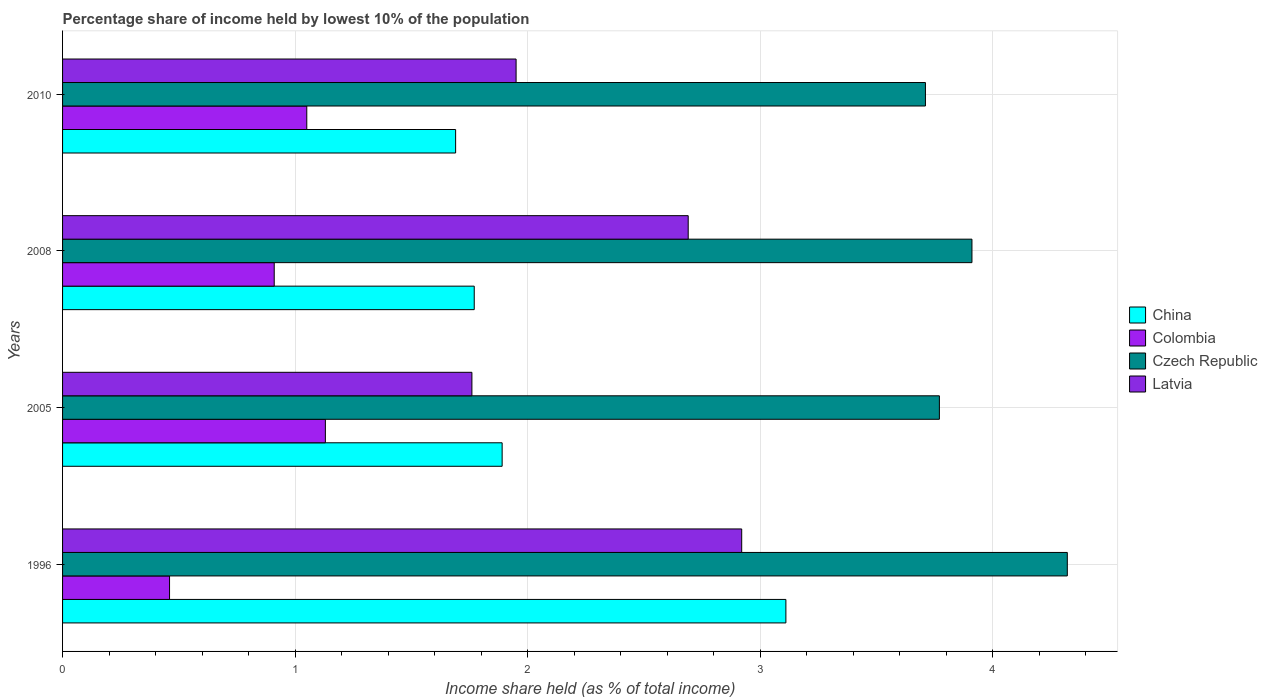How many groups of bars are there?
Your response must be concise. 4. What is the label of the 4th group of bars from the top?
Ensure brevity in your answer.  1996. In how many cases, is the number of bars for a given year not equal to the number of legend labels?
Keep it short and to the point. 0. What is the percentage share of income held by lowest 10% of the population in China in 2008?
Your answer should be compact. 1.77. Across all years, what is the maximum percentage share of income held by lowest 10% of the population in Czech Republic?
Offer a very short reply. 4.32. Across all years, what is the minimum percentage share of income held by lowest 10% of the population in Latvia?
Make the answer very short. 1.76. In which year was the percentage share of income held by lowest 10% of the population in Latvia maximum?
Provide a succinct answer. 1996. In which year was the percentage share of income held by lowest 10% of the population in Colombia minimum?
Ensure brevity in your answer.  1996. What is the total percentage share of income held by lowest 10% of the population in Czech Republic in the graph?
Ensure brevity in your answer.  15.71. What is the difference between the percentage share of income held by lowest 10% of the population in Czech Republic in 2008 and that in 2010?
Make the answer very short. 0.2. What is the difference between the percentage share of income held by lowest 10% of the population in Latvia in 2005 and the percentage share of income held by lowest 10% of the population in Czech Republic in 2008?
Provide a succinct answer. -2.15. What is the average percentage share of income held by lowest 10% of the population in Colombia per year?
Provide a succinct answer. 0.89. What is the ratio of the percentage share of income held by lowest 10% of the population in Colombia in 1996 to that in 2008?
Offer a terse response. 0.51. Is the percentage share of income held by lowest 10% of the population in China in 1996 less than that in 2008?
Keep it short and to the point. No. Is the difference between the percentage share of income held by lowest 10% of the population in Colombia in 1996 and 2005 greater than the difference between the percentage share of income held by lowest 10% of the population in Czech Republic in 1996 and 2005?
Give a very brief answer. No. What is the difference between the highest and the second highest percentage share of income held by lowest 10% of the population in China?
Your response must be concise. 1.22. What is the difference between the highest and the lowest percentage share of income held by lowest 10% of the population in China?
Your response must be concise. 1.42. Is the sum of the percentage share of income held by lowest 10% of the population in Czech Republic in 2005 and 2010 greater than the maximum percentage share of income held by lowest 10% of the population in Latvia across all years?
Offer a terse response. Yes. Is it the case that in every year, the sum of the percentage share of income held by lowest 10% of the population in Czech Republic and percentage share of income held by lowest 10% of the population in Latvia is greater than the sum of percentage share of income held by lowest 10% of the population in China and percentage share of income held by lowest 10% of the population in Colombia?
Your answer should be compact. No. What does the 1st bar from the top in 2005 represents?
Provide a short and direct response. Latvia. What does the 3rd bar from the bottom in 1996 represents?
Provide a short and direct response. Czech Republic. Is it the case that in every year, the sum of the percentage share of income held by lowest 10% of the population in Czech Republic and percentage share of income held by lowest 10% of the population in Latvia is greater than the percentage share of income held by lowest 10% of the population in Colombia?
Keep it short and to the point. Yes. What is the difference between two consecutive major ticks on the X-axis?
Offer a terse response. 1. Does the graph contain any zero values?
Your answer should be very brief. No. Does the graph contain grids?
Provide a succinct answer. Yes. Where does the legend appear in the graph?
Offer a terse response. Center right. What is the title of the graph?
Your response must be concise. Percentage share of income held by lowest 10% of the population. Does "St. Lucia" appear as one of the legend labels in the graph?
Your answer should be compact. No. What is the label or title of the X-axis?
Give a very brief answer. Income share held (as % of total income). What is the label or title of the Y-axis?
Keep it short and to the point. Years. What is the Income share held (as % of total income) of China in 1996?
Provide a succinct answer. 3.11. What is the Income share held (as % of total income) in Colombia in 1996?
Offer a terse response. 0.46. What is the Income share held (as % of total income) in Czech Republic in 1996?
Ensure brevity in your answer.  4.32. What is the Income share held (as % of total income) of Latvia in 1996?
Your answer should be compact. 2.92. What is the Income share held (as % of total income) of China in 2005?
Provide a short and direct response. 1.89. What is the Income share held (as % of total income) of Colombia in 2005?
Your answer should be compact. 1.13. What is the Income share held (as % of total income) of Czech Republic in 2005?
Provide a succinct answer. 3.77. What is the Income share held (as % of total income) in Latvia in 2005?
Provide a succinct answer. 1.76. What is the Income share held (as % of total income) of China in 2008?
Give a very brief answer. 1.77. What is the Income share held (as % of total income) of Colombia in 2008?
Keep it short and to the point. 0.91. What is the Income share held (as % of total income) in Czech Republic in 2008?
Provide a short and direct response. 3.91. What is the Income share held (as % of total income) of Latvia in 2008?
Make the answer very short. 2.69. What is the Income share held (as % of total income) of China in 2010?
Your answer should be very brief. 1.69. What is the Income share held (as % of total income) of Colombia in 2010?
Provide a succinct answer. 1.05. What is the Income share held (as % of total income) in Czech Republic in 2010?
Offer a very short reply. 3.71. What is the Income share held (as % of total income) in Latvia in 2010?
Ensure brevity in your answer.  1.95. Across all years, what is the maximum Income share held (as % of total income) of China?
Your answer should be very brief. 3.11. Across all years, what is the maximum Income share held (as % of total income) in Colombia?
Your answer should be compact. 1.13. Across all years, what is the maximum Income share held (as % of total income) in Czech Republic?
Ensure brevity in your answer.  4.32. Across all years, what is the maximum Income share held (as % of total income) in Latvia?
Provide a succinct answer. 2.92. Across all years, what is the minimum Income share held (as % of total income) of China?
Your response must be concise. 1.69. Across all years, what is the minimum Income share held (as % of total income) of Colombia?
Make the answer very short. 0.46. Across all years, what is the minimum Income share held (as % of total income) of Czech Republic?
Make the answer very short. 3.71. Across all years, what is the minimum Income share held (as % of total income) of Latvia?
Ensure brevity in your answer.  1.76. What is the total Income share held (as % of total income) of China in the graph?
Ensure brevity in your answer.  8.46. What is the total Income share held (as % of total income) in Colombia in the graph?
Provide a short and direct response. 3.55. What is the total Income share held (as % of total income) in Czech Republic in the graph?
Your response must be concise. 15.71. What is the total Income share held (as % of total income) in Latvia in the graph?
Give a very brief answer. 9.32. What is the difference between the Income share held (as % of total income) of China in 1996 and that in 2005?
Your answer should be compact. 1.22. What is the difference between the Income share held (as % of total income) of Colombia in 1996 and that in 2005?
Give a very brief answer. -0.67. What is the difference between the Income share held (as % of total income) in Czech Republic in 1996 and that in 2005?
Make the answer very short. 0.55. What is the difference between the Income share held (as % of total income) in Latvia in 1996 and that in 2005?
Your answer should be very brief. 1.16. What is the difference between the Income share held (as % of total income) of China in 1996 and that in 2008?
Make the answer very short. 1.34. What is the difference between the Income share held (as % of total income) in Colombia in 1996 and that in 2008?
Offer a terse response. -0.45. What is the difference between the Income share held (as % of total income) in Czech Republic in 1996 and that in 2008?
Offer a terse response. 0.41. What is the difference between the Income share held (as % of total income) of Latvia in 1996 and that in 2008?
Offer a terse response. 0.23. What is the difference between the Income share held (as % of total income) in China in 1996 and that in 2010?
Your answer should be compact. 1.42. What is the difference between the Income share held (as % of total income) of Colombia in 1996 and that in 2010?
Offer a terse response. -0.59. What is the difference between the Income share held (as % of total income) of Czech Republic in 1996 and that in 2010?
Provide a succinct answer. 0.61. What is the difference between the Income share held (as % of total income) of China in 2005 and that in 2008?
Make the answer very short. 0.12. What is the difference between the Income share held (as % of total income) in Colombia in 2005 and that in 2008?
Offer a very short reply. 0.22. What is the difference between the Income share held (as % of total income) in Czech Republic in 2005 and that in 2008?
Keep it short and to the point. -0.14. What is the difference between the Income share held (as % of total income) in Latvia in 2005 and that in 2008?
Ensure brevity in your answer.  -0.93. What is the difference between the Income share held (as % of total income) of Colombia in 2005 and that in 2010?
Offer a very short reply. 0.08. What is the difference between the Income share held (as % of total income) in Latvia in 2005 and that in 2010?
Your response must be concise. -0.19. What is the difference between the Income share held (as % of total income) of China in 2008 and that in 2010?
Offer a terse response. 0.08. What is the difference between the Income share held (as % of total income) of Colombia in 2008 and that in 2010?
Your answer should be very brief. -0.14. What is the difference between the Income share held (as % of total income) in Latvia in 2008 and that in 2010?
Keep it short and to the point. 0.74. What is the difference between the Income share held (as % of total income) in China in 1996 and the Income share held (as % of total income) in Colombia in 2005?
Keep it short and to the point. 1.98. What is the difference between the Income share held (as % of total income) of China in 1996 and the Income share held (as % of total income) of Czech Republic in 2005?
Your answer should be very brief. -0.66. What is the difference between the Income share held (as % of total income) of China in 1996 and the Income share held (as % of total income) of Latvia in 2005?
Your answer should be very brief. 1.35. What is the difference between the Income share held (as % of total income) in Colombia in 1996 and the Income share held (as % of total income) in Czech Republic in 2005?
Your response must be concise. -3.31. What is the difference between the Income share held (as % of total income) in Colombia in 1996 and the Income share held (as % of total income) in Latvia in 2005?
Keep it short and to the point. -1.3. What is the difference between the Income share held (as % of total income) of Czech Republic in 1996 and the Income share held (as % of total income) of Latvia in 2005?
Make the answer very short. 2.56. What is the difference between the Income share held (as % of total income) in China in 1996 and the Income share held (as % of total income) in Colombia in 2008?
Offer a very short reply. 2.2. What is the difference between the Income share held (as % of total income) of China in 1996 and the Income share held (as % of total income) of Latvia in 2008?
Your response must be concise. 0.42. What is the difference between the Income share held (as % of total income) in Colombia in 1996 and the Income share held (as % of total income) in Czech Republic in 2008?
Your answer should be very brief. -3.45. What is the difference between the Income share held (as % of total income) of Colombia in 1996 and the Income share held (as % of total income) of Latvia in 2008?
Give a very brief answer. -2.23. What is the difference between the Income share held (as % of total income) in Czech Republic in 1996 and the Income share held (as % of total income) in Latvia in 2008?
Your response must be concise. 1.63. What is the difference between the Income share held (as % of total income) of China in 1996 and the Income share held (as % of total income) of Colombia in 2010?
Your response must be concise. 2.06. What is the difference between the Income share held (as % of total income) in China in 1996 and the Income share held (as % of total income) in Czech Republic in 2010?
Your answer should be compact. -0.6. What is the difference between the Income share held (as % of total income) in China in 1996 and the Income share held (as % of total income) in Latvia in 2010?
Offer a very short reply. 1.16. What is the difference between the Income share held (as % of total income) in Colombia in 1996 and the Income share held (as % of total income) in Czech Republic in 2010?
Make the answer very short. -3.25. What is the difference between the Income share held (as % of total income) in Colombia in 1996 and the Income share held (as % of total income) in Latvia in 2010?
Offer a terse response. -1.49. What is the difference between the Income share held (as % of total income) in Czech Republic in 1996 and the Income share held (as % of total income) in Latvia in 2010?
Make the answer very short. 2.37. What is the difference between the Income share held (as % of total income) of China in 2005 and the Income share held (as % of total income) of Colombia in 2008?
Your response must be concise. 0.98. What is the difference between the Income share held (as % of total income) in China in 2005 and the Income share held (as % of total income) in Czech Republic in 2008?
Your response must be concise. -2.02. What is the difference between the Income share held (as % of total income) in Colombia in 2005 and the Income share held (as % of total income) in Czech Republic in 2008?
Make the answer very short. -2.78. What is the difference between the Income share held (as % of total income) in Colombia in 2005 and the Income share held (as % of total income) in Latvia in 2008?
Ensure brevity in your answer.  -1.56. What is the difference between the Income share held (as % of total income) in China in 2005 and the Income share held (as % of total income) in Colombia in 2010?
Provide a succinct answer. 0.84. What is the difference between the Income share held (as % of total income) in China in 2005 and the Income share held (as % of total income) in Czech Republic in 2010?
Ensure brevity in your answer.  -1.82. What is the difference between the Income share held (as % of total income) in China in 2005 and the Income share held (as % of total income) in Latvia in 2010?
Keep it short and to the point. -0.06. What is the difference between the Income share held (as % of total income) in Colombia in 2005 and the Income share held (as % of total income) in Czech Republic in 2010?
Your response must be concise. -2.58. What is the difference between the Income share held (as % of total income) in Colombia in 2005 and the Income share held (as % of total income) in Latvia in 2010?
Your answer should be very brief. -0.82. What is the difference between the Income share held (as % of total income) in Czech Republic in 2005 and the Income share held (as % of total income) in Latvia in 2010?
Make the answer very short. 1.82. What is the difference between the Income share held (as % of total income) of China in 2008 and the Income share held (as % of total income) of Colombia in 2010?
Give a very brief answer. 0.72. What is the difference between the Income share held (as % of total income) in China in 2008 and the Income share held (as % of total income) in Czech Republic in 2010?
Give a very brief answer. -1.94. What is the difference between the Income share held (as % of total income) in China in 2008 and the Income share held (as % of total income) in Latvia in 2010?
Make the answer very short. -0.18. What is the difference between the Income share held (as % of total income) of Colombia in 2008 and the Income share held (as % of total income) of Latvia in 2010?
Offer a very short reply. -1.04. What is the difference between the Income share held (as % of total income) of Czech Republic in 2008 and the Income share held (as % of total income) of Latvia in 2010?
Keep it short and to the point. 1.96. What is the average Income share held (as % of total income) in China per year?
Your answer should be compact. 2.12. What is the average Income share held (as % of total income) of Colombia per year?
Keep it short and to the point. 0.89. What is the average Income share held (as % of total income) of Czech Republic per year?
Offer a very short reply. 3.93. What is the average Income share held (as % of total income) in Latvia per year?
Your answer should be very brief. 2.33. In the year 1996, what is the difference between the Income share held (as % of total income) of China and Income share held (as % of total income) of Colombia?
Provide a short and direct response. 2.65. In the year 1996, what is the difference between the Income share held (as % of total income) of China and Income share held (as % of total income) of Czech Republic?
Your answer should be compact. -1.21. In the year 1996, what is the difference between the Income share held (as % of total income) of China and Income share held (as % of total income) of Latvia?
Offer a terse response. 0.19. In the year 1996, what is the difference between the Income share held (as % of total income) of Colombia and Income share held (as % of total income) of Czech Republic?
Your answer should be compact. -3.86. In the year 1996, what is the difference between the Income share held (as % of total income) of Colombia and Income share held (as % of total income) of Latvia?
Provide a short and direct response. -2.46. In the year 1996, what is the difference between the Income share held (as % of total income) of Czech Republic and Income share held (as % of total income) of Latvia?
Provide a short and direct response. 1.4. In the year 2005, what is the difference between the Income share held (as % of total income) of China and Income share held (as % of total income) of Colombia?
Your answer should be very brief. 0.76. In the year 2005, what is the difference between the Income share held (as % of total income) of China and Income share held (as % of total income) of Czech Republic?
Ensure brevity in your answer.  -1.88. In the year 2005, what is the difference between the Income share held (as % of total income) of China and Income share held (as % of total income) of Latvia?
Make the answer very short. 0.13. In the year 2005, what is the difference between the Income share held (as % of total income) in Colombia and Income share held (as % of total income) in Czech Republic?
Provide a succinct answer. -2.64. In the year 2005, what is the difference between the Income share held (as % of total income) of Colombia and Income share held (as % of total income) of Latvia?
Ensure brevity in your answer.  -0.63. In the year 2005, what is the difference between the Income share held (as % of total income) of Czech Republic and Income share held (as % of total income) of Latvia?
Provide a short and direct response. 2.01. In the year 2008, what is the difference between the Income share held (as % of total income) of China and Income share held (as % of total income) of Colombia?
Your answer should be very brief. 0.86. In the year 2008, what is the difference between the Income share held (as % of total income) in China and Income share held (as % of total income) in Czech Republic?
Keep it short and to the point. -2.14. In the year 2008, what is the difference between the Income share held (as % of total income) in China and Income share held (as % of total income) in Latvia?
Your response must be concise. -0.92. In the year 2008, what is the difference between the Income share held (as % of total income) in Colombia and Income share held (as % of total income) in Czech Republic?
Keep it short and to the point. -3. In the year 2008, what is the difference between the Income share held (as % of total income) of Colombia and Income share held (as % of total income) of Latvia?
Your response must be concise. -1.78. In the year 2008, what is the difference between the Income share held (as % of total income) in Czech Republic and Income share held (as % of total income) in Latvia?
Provide a succinct answer. 1.22. In the year 2010, what is the difference between the Income share held (as % of total income) in China and Income share held (as % of total income) in Colombia?
Provide a succinct answer. 0.64. In the year 2010, what is the difference between the Income share held (as % of total income) in China and Income share held (as % of total income) in Czech Republic?
Give a very brief answer. -2.02. In the year 2010, what is the difference between the Income share held (as % of total income) of China and Income share held (as % of total income) of Latvia?
Your answer should be very brief. -0.26. In the year 2010, what is the difference between the Income share held (as % of total income) in Colombia and Income share held (as % of total income) in Czech Republic?
Keep it short and to the point. -2.66. In the year 2010, what is the difference between the Income share held (as % of total income) in Colombia and Income share held (as % of total income) in Latvia?
Provide a short and direct response. -0.9. In the year 2010, what is the difference between the Income share held (as % of total income) in Czech Republic and Income share held (as % of total income) in Latvia?
Ensure brevity in your answer.  1.76. What is the ratio of the Income share held (as % of total income) in China in 1996 to that in 2005?
Make the answer very short. 1.65. What is the ratio of the Income share held (as % of total income) of Colombia in 1996 to that in 2005?
Your answer should be very brief. 0.41. What is the ratio of the Income share held (as % of total income) of Czech Republic in 1996 to that in 2005?
Provide a succinct answer. 1.15. What is the ratio of the Income share held (as % of total income) of Latvia in 1996 to that in 2005?
Ensure brevity in your answer.  1.66. What is the ratio of the Income share held (as % of total income) of China in 1996 to that in 2008?
Give a very brief answer. 1.76. What is the ratio of the Income share held (as % of total income) in Colombia in 1996 to that in 2008?
Offer a terse response. 0.51. What is the ratio of the Income share held (as % of total income) in Czech Republic in 1996 to that in 2008?
Provide a succinct answer. 1.1. What is the ratio of the Income share held (as % of total income) in Latvia in 1996 to that in 2008?
Make the answer very short. 1.09. What is the ratio of the Income share held (as % of total income) in China in 1996 to that in 2010?
Give a very brief answer. 1.84. What is the ratio of the Income share held (as % of total income) in Colombia in 1996 to that in 2010?
Ensure brevity in your answer.  0.44. What is the ratio of the Income share held (as % of total income) in Czech Republic in 1996 to that in 2010?
Make the answer very short. 1.16. What is the ratio of the Income share held (as % of total income) of Latvia in 1996 to that in 2010?
Provide a succinct answer. 1.5. What is the ratio of the Income share held (as % of total income) of China in 2005 to that in 2008?
Keep it short and to the point. 1.07. What is the ratio of the Income share held (as % of total income) of Colombia in 2005 to that in 2008?
Make the answer very short. 1.24. What is the ratio of the Income share held (as % of total income) in Czech Republic in 2005 to that in 2008?
Your answer should be very brief. 0.96. What is the ratio of the Income share held (as % of total income) in Latvia in 2005 to that in 2008?
Your answer should be very brief. 0.65. What is the ratio of the Income share held (as % of total income) in China in 2005 to that in 2010?
Give a very brief answer. 1.12. What is the ratio of the Income share held (as % of total income) in Colombia in 2005 to that in 2010?
Keep it short and to the point. 1.08. What is the ratio of the Income share held (as % of total income) of Czech Republic in 2005 to that in 2010?
Give a very brief answer. 1.02. What is the ratio of the Income share held (as % of total income) in Latvia in 2005 to that in 2010?
Your answer should be very brief. 0.9. What is the ratio of the Income share held (as % of total income) of China in 2008 to that in 2010?
Your answer should be compact. 1.05. What is the ratio of the Income share held (as % of total income) in Colombia in 2008 to that in 2010?
Make the answer very short. 0.87. What is the ratio of the Income share held (as % of total income) of Czech Republic in 2008 to that in 2010?
Your answer should be very brief. 1.05. What is the ratio of the Income share held (as % of total income) of Latvia in 2008 to that in 2010?
Your answer should be compact. 1.38. What is the difference between the highest and the second highest Income share held (as % of total income) of China?
Offer a very short reply. 1.22. What is the difference between the highest and the second highest Income share held (as % of total income) of Czech Republic?
Make the answer very short. 0.41. What is the difference between the highest and the second highest Income share held (as % of total income) of Latvia?
Provide a succinct answer. 0.23. What is the difference between the highest and the lowest Income share held (as % of total income) of China?
Your response must be concise. 1.42. What is the difference between the highest and the lowest Income share held (as % of total income) of Colombia?
Make the answer very short. 0.67. What is the difference between the highest and the lowest Income share held (as % of total income) of Czech Republic?
Your response must be concise. 0.61. What is the difference between the highest and the lowest Income share held (as % of total income) of Latvia?
Your answer should be very brief. 1.16. 